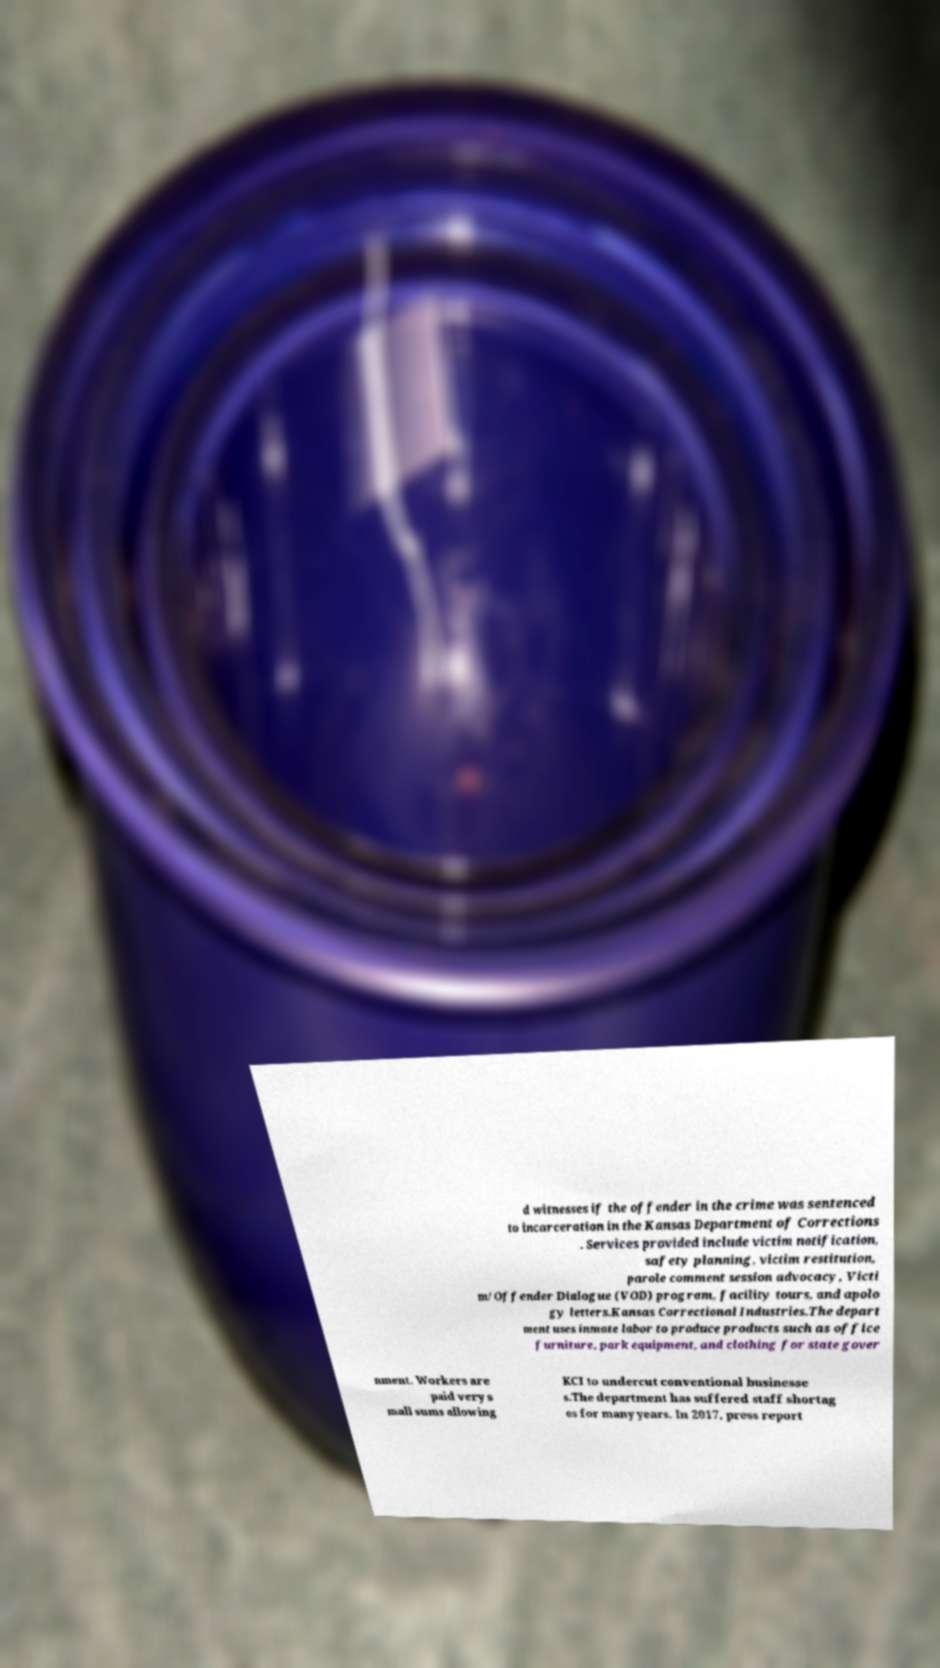Could you extract and type out the text from this image? d witnesses if the offender in the crime was sentenced to incarceration in the Kansas Department of Corrections . Services provided include victim notification, safety planning, victim restitution, parole comment session advocacy, Victi m/Offender Dialogue (VOD) program, facility tours, and apolo gy letters.Kansas Correctional Industries.The depart ment uses inmate labor to produce products such as office furniture, park equipment, and clothing for state gover nment. Workers are paid very s mall sums allowing KCI to undercut conventional businesse s.The department has suffered staff shortag es for many years. In 2017, press report 